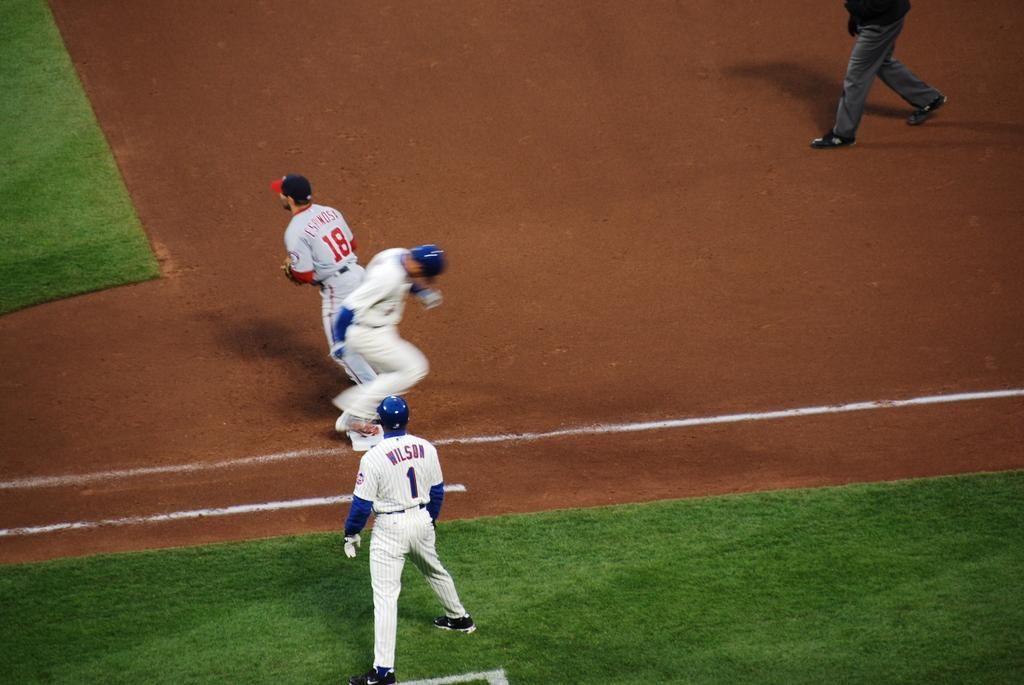Who is present in the image? There are people in the image. What activity are the people engaged in? The people are playing baseball. Where is the baseball game taking place? The game is taking place on the ground. What type of net can be seen in the image? There is no net present in the image; it features people playing baseball on the ground. What kind of lumber is being used by the players in the image? There is no lumber visible in the image; the players are using baseball equipment such as bats and gloves. 